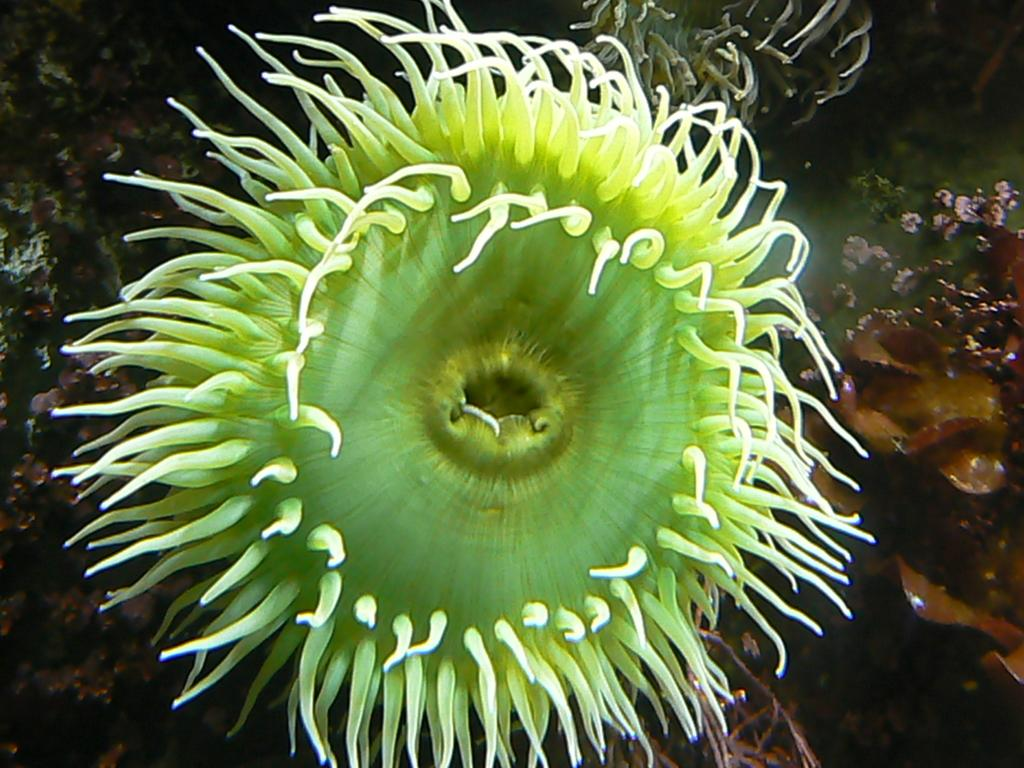What type of plant can be seen in the image? There is a green color sea plant in the image. What other objects can be seen in the image? There are corals visible in the image. What type of servant can be seen working in the image? There is no servant present in the image; it features a green color sea plant and corals. What type of thread is used to create the corals in the image? The image does not depict any thread or crafting materials; it is a photograph or illustration of real sea plants and corals. 